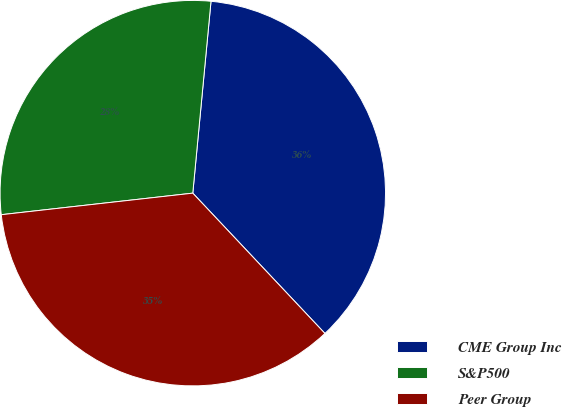Convert chart to OTSL. <chart><loc_0><loc_0><loc_500><loc_500><pie_chart><fcel>CME Group Inc<fcel>S&P500<fcel>Peer Group<nl><fcel>36.47%<fcel>28.29%<fcel>35.24%<nl></chart> 